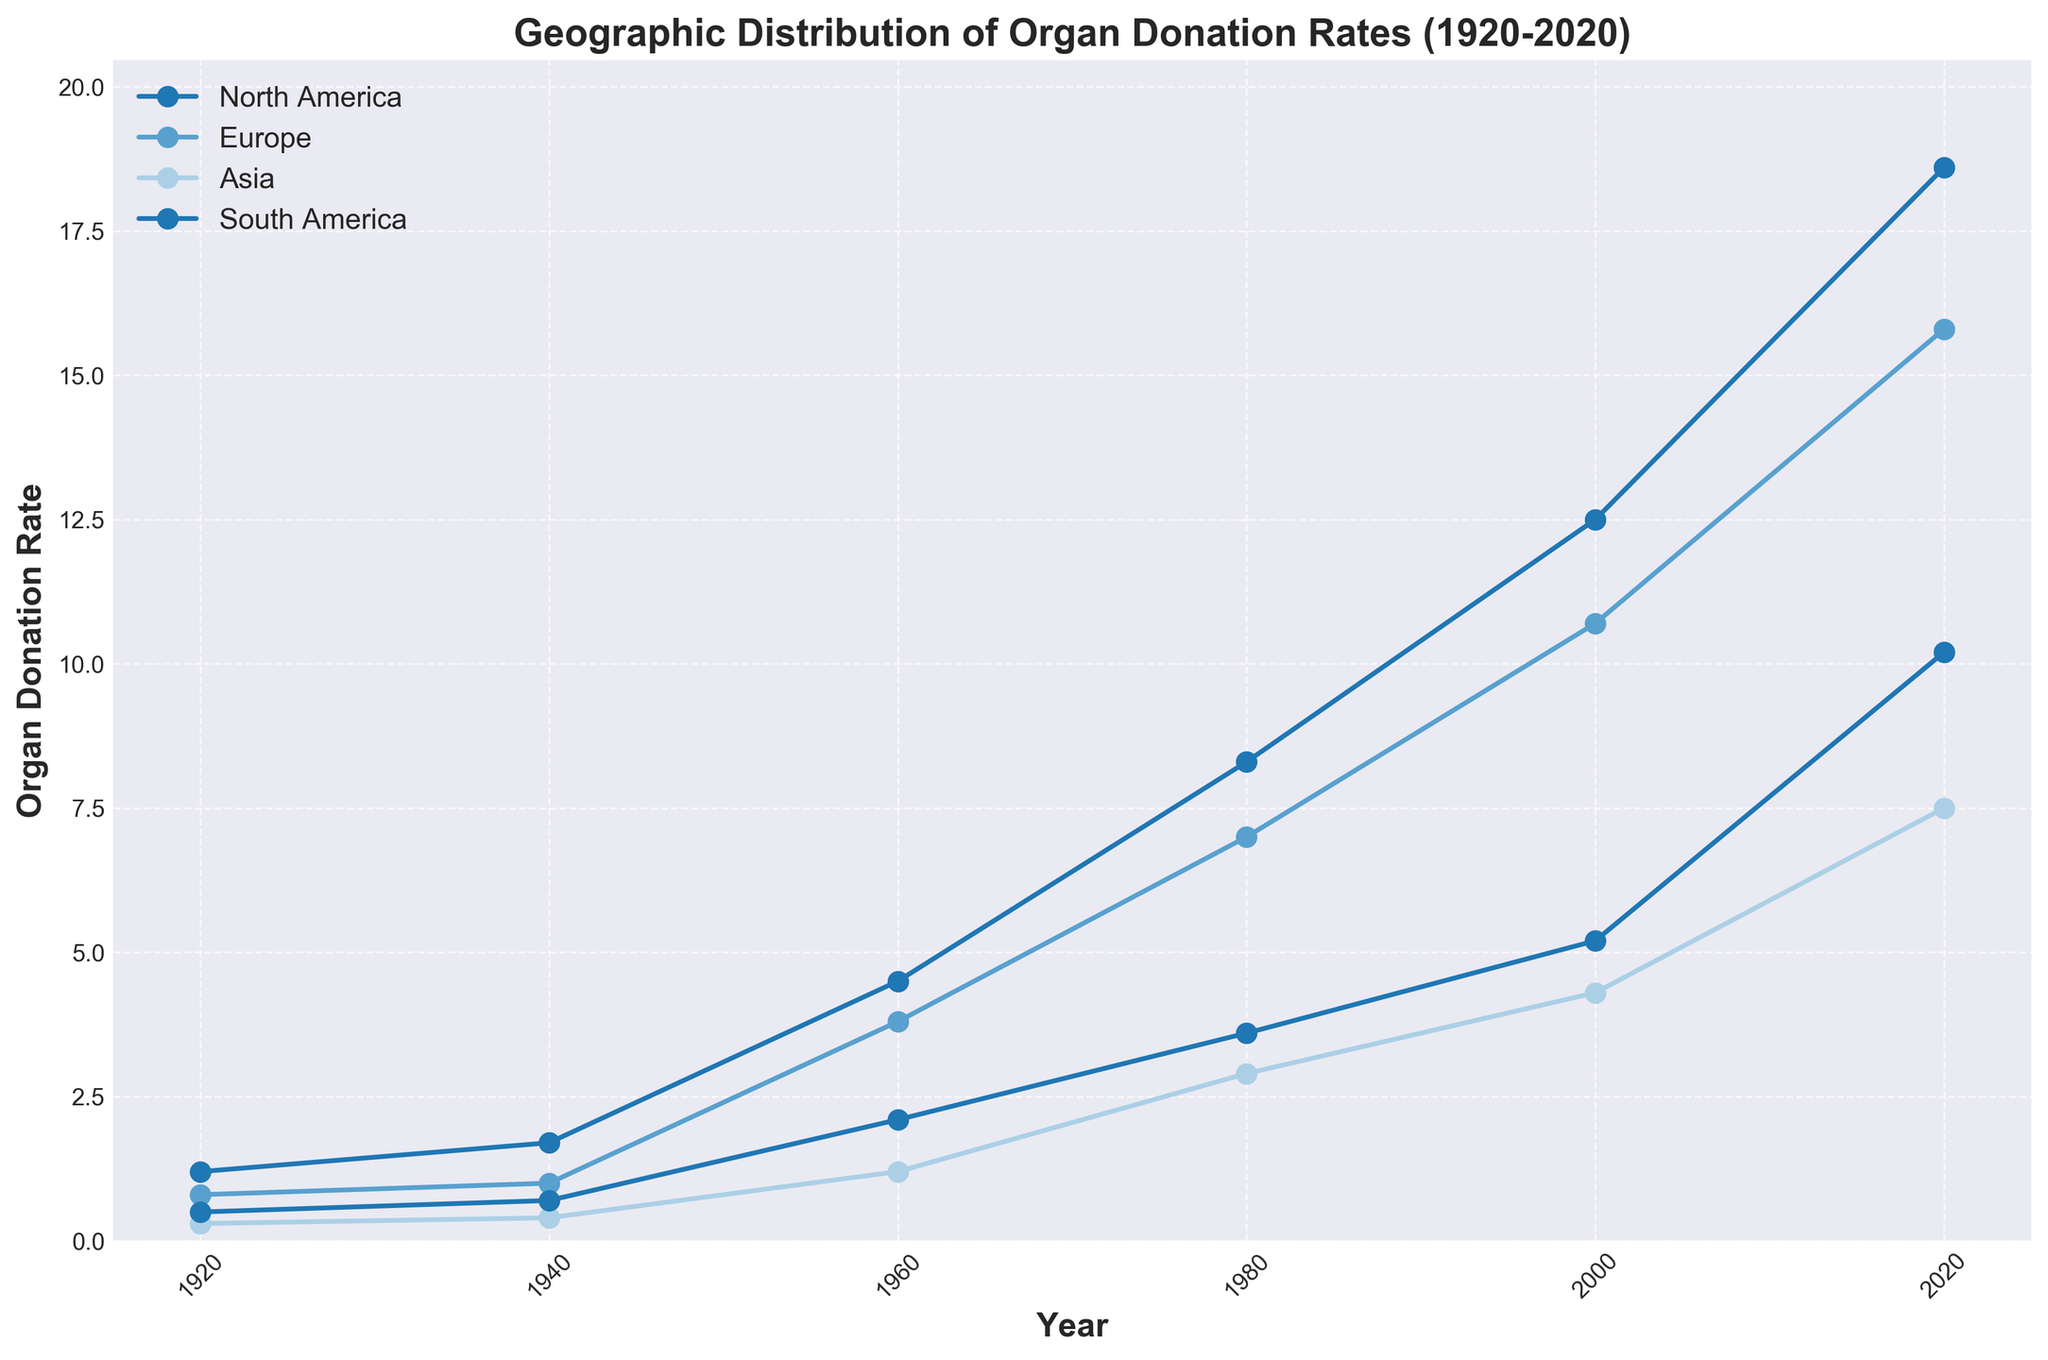What regions are depicted in the figure? The figure illustrates the geographic distribution of organ donation rates across different regions. The regions are labeled in the legend of the plot.
Answer: North America, Europe, Asia, South America What is the title of the plot? The title of the plot is usually found at the top-center of the figure. It serves as a summary of what the figure is about.
Answer: Geographic Distribution of Organ Donation Rates (1920-2020) Which region had the highest organ donation rate in 2020? To determine the highest organ donation rate in 2020, we look at the data points for each region in 2020 and compare their values.
Answer: North America What was the organ donation rate for Europe in 1960? Locate the data point for Europe in the year 1960 on the X-axis and read off the corresponding Y-axis value.
Answer: 3.8 By how much did the organ donation rate in Asia increase from 1920 to 2020? To find the increase, subtract the organ donation rate in 1920 from the rate in 2020 for Asia.
Answer: 7.2 Which region showed the most significant increase in organ donation rates from 1920 to 2020? To find the region with the most significant increase, calculate the difference in organ donation rates from 1920 to 2020 for each region and identify the greatest value.
Answer: North America Compare the organ donation rates in South America and Asia in 1980. Which region had a higher rate? Look at the data points for South America and Asia in the year 1980 and compare their Y-axis values.
Answer: South America What is the general trend of organ donation rates in North America from 1920 to 2020? Observe the plotted line for North America and note how the values change chronologically from 1920 to 2020.
Answer: Increasing trend Which year exhibits the greatest difference in organ donation rates between Europe and South America? For each year, calculate the difference between the organ donation rates of Europe and South America, and identify the year with the greatest difference.
Answer: 2020 In which period did Europe see the steepest increase in organ donation rate, based on the figure? Analyze the slope of the line for Europe in different periods (e.g., 1920-1940, 1940-1960, etc.) and identify the period with the steepest upward slope.
Answer: 1960 to 1980 